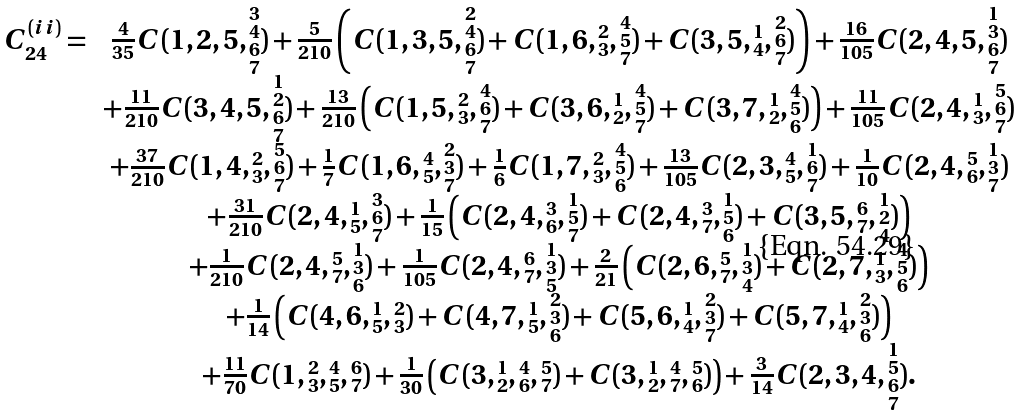Convert formula to latex. <formula><loc_0><loc_0><loc_500><loc_500>\begin{array} { r c } C ^ { ( i i ) } _ { 2 4 } = & \frac { 4 } { 3 5 } C ( 1 , 2 , 5 , \substack { 3 \\ 4 \\ 6 \\ 7 } ) + \frac { 5 } { 2 1 0 } \left ( C ( 1 , 3 , 5 , \substack { 2 \\ 4 \\ 6 \\ 7 } ) + C ( 1 , 6 , \substack { 2 \\ 3 } , \substack { 4 \\ 5 \\ 7 } ) + C ( 3 , 5 , \substack { 1 \\ 4 } , \substack { 2 \\ 6 \\ 7 } ) \right ) + \frac { 1 6 } { 1 0 5 } C ( 2 , 4 , 5 , \substack { 1 \\ 3 \\ 6 \\ 7 } ) \\ & + \frac { 1 1 } { 2 1 0 } C ( 3 , 4 , 5 , \substack { 1 \\ 2 \\ 6 \\ 7 } ) + \frac { 1 3 } { 2 1 0 } \left ( C ( 1 , 5 , \substack { 2 \\ 3 } , \substack { 4 \\ 6 \\ 7 } ) + C ( 3 , 6 , \substack { 1 \\ 2 } , \substack { 4 \\ 5 \\ 7 } ) + C ( 3 , 7 , \substack { 1 \\ 2 } , \substack { 4 \\ 5 \\ 6 } ) \right ) + \frac { 1 1 } { 1 0 5 } C ( 2 , 4 , \substack { 1 \\ 3 } , \substack { 5 \\ 6 \\ 7 } ) \\ & + \frac { 3 7 } { 2 1 0 } C ( 1 , 4 , \substack { 2 \\ 3 } , \substack { 5 \\ 6 \\ 7 } ) + \frac { 1 } { 7 } C ( 1 , 6 , \substack { 4 \\ 5 } , \substack { 2 \\ 3 \\ 7 } ) + \frac { 1 } { 6 } C ( 1 , 7 , \substack { 2 \\ 3 } , \substack { 4 \\ 5 \\ 6 } ) + \frac { 1 3 } { 1 0 5 } C ( 2 , 3 , \substack { 4 \\ 5 } , \substack { 1 \\ 6 \\ 7 } ) + \frac { 1 } { 1 0 } C ( 2 , 4 , \substack { 5 \\ 6 } , \substack { 1 \\ 3 \\ 7 } ) \\ & + \frac { 3 1 } { 2 1 0 } C ( 2 , 4 , \substack { 1 \\ 5 } , \substack { 3 \\ 6 \\ 7 } ) + \frac { 1 } { 1 5 } \left ( C ( 2 , 4 , \substack { 3 \\ 6 } , \substack { 1 \\ 5 \\ 7 } ) + C ( 2 , 4 , \substack { 3 \\ 7 } , \substack { 1 \\ 5 \\ 6 } ) + C ( 3 , 5 , \substack { 6 \\ 7 } , \substack { 1 \\ 2 \\ 4 } ) \right ) \\ & + \frac { 1 } { 2 1 0 } C ( 2 , 4 , \substack { 5 \\ 7 } , \substack { 1 \\ 3 \\ 6 } ) + \frac { 1 } { 1 0 5 } C ( 2 , 4 , \substack { 6 \\ 7 } , \substack { 1 \\ 3 \\ 5 } ) + \frac { 2 } { 2 1 } \left ( C ( 2 , 6 , \substack { 5 \\ 7 } , \substack { 1 \\ 3 \\ 4 } ) + C ( 2 , 7 , \substack { 1 \\ 3 } , \substack { 4 \\ 5 \\ 6 } ) \right ) \\ & + \frac { 1 } { 1 4 } \left ( C ( 4 , 6 , \substack { 1 \\ 5 } , \substack { 2 \\ 3 } ) + C ( 4 , 7 , \substack { 1 \\ 5 } , \substack { 2 \\ 3 \\ 6 } ) + C ( 5 , 6 , \substack { 1 \\ 4 } , \substack { 2 \\ 3 \\ 7 } ) + C ( 5 , 7 , \substack { 1 \\ 4 } , \substack { 2 \\ 3 \\ 6 } ) \right ) \\ & + \frac { 1 1 } { 7 0 } C ( 1 , \substack { 2 \\ 3 } , \substack { 4 \\ 5 } , \substack { 6 \\ 7 } ) + \frac { 1 } { 3 0 } \left ( C ( 3 , \substack { 1 \\ 2 } , \substack { 4 \\ 6 } , \substack { 5 \\ 7 } ) + C ( 3 , \substack { 1 \\ 2 } , \substack { 4 \\ 7 } , \substack { 5 \\ 6 } ) \right ) + \frac { 3 } { 1 4 } C ( 2 , 3 , 4 , \substack { 1 \\ 5 \\ 6 \\ 7 } ) . \end{array}</formula> 